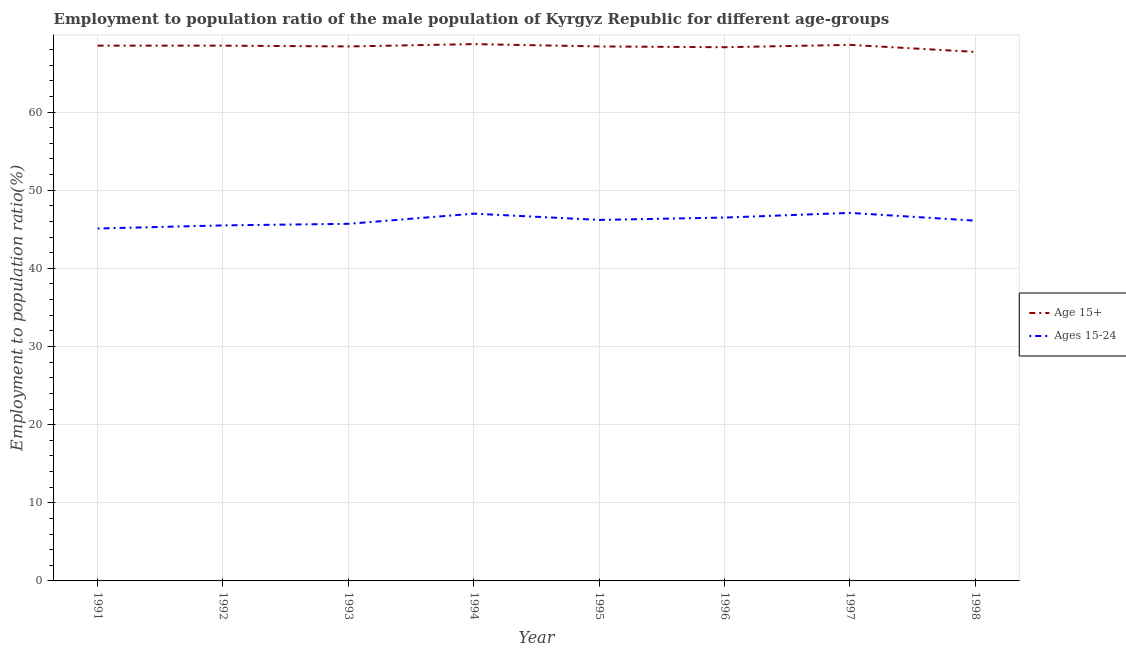How many different coloured lines are there?
Give a very brief answer. 2. Is the number of lines equal to the number of legend labels?
Provide a succinct answer. Yes. What is the employment to population ratio(age 15-24) in 1996?
Offer a terse response. 46.5. Across all years, what is the maximum employment to population ratio(age 15-24)?
Your response must be concise. 47.1. Across all years, what is the minimum employment to population ratio(age 15-24)?
Make the answer very short. 45.1. What is the total employment to population ratio(age 15-24) in the graph?
Keep it short and to the point. 369.2. What is the difference between the employment to population ratio(age 15+) in 1992 and that in 1998?
Provide a short and direct response. 0.8. What is the difference between the employment to population ratio(age 15-24) in 1991 and the employment to population ratio(age 15+) in 1994?
Offer a very short reply. -23.6. What is the average employment to population ratio(age 15-24) per year?
Make the answer very short. 46.15. In the year 1995, what is the difference between the employment to population ratio(age 15+) and employment to population ratio(age 15-24)?
Your response must be concise. 22.2. In how many years, is the employment to population ratio(age 15-24) greater than 18 %?
Ensure brevity in your answer.  8. What is the ratio of the employment to population ratio(age 15-24) in 1991 to that in 1998?
Offer a very short reply. 0.98. What is the difference between the highest and the second highest employment to population ratio(age 15-24)?
Your answer should be very brief. 0.1. In how many years, is the employment to population ratio(age 15-24) greater than the average employment to population ratio(age 15-24) taken over all years?
Offer a terse response. 4. What is the difference between two consecutive major ticks on the Y-axis?
Ensure brevity in your answer.  10. Does the graph contain any zero values?
Offer a terse response. No. Does the graph contain grids?
Provide a short and direct response. Yes. Where does the legend appear in the graph?
Give a very brief answer. Center right. How many legend labels are there?
Ensure brevity in your answer.  2. How are the legend labels stacked?
Make the answer very short. Vertical. What is the title of the graph?
Keep it short and to the point. Employment to population ratio of the male population of Kyrgyz Republic for different age-groups. Does "Manufacturing industries and construction" appear as one of the legend labels in the graph?
Your answer should be compact. No. What is the label or title of the X-axis?
Your answer should be compact. Year. What is the label or title of the Y-axis?
Offer a very short reply. Employment to population ratio(%). What is the Employment to population ratio(%) of Age 15+ in 1991?
Give a very brief answer. 68.5. What is the Employment to population ratio(%) in Ages 15-24 in 1991?
Give a very brief answer. 45.1. What is the Employment to population ratio(%) in Age 15+ in 1992?
Keep it short and to the point. 68.5. What is the Employment to population ratio(%) in Ages 15-24 in 1992?
Provide a short and direct response. 45.5. What is the Employment to population ratio(%) in Age 15+ in 1993?
Your response must be concise. 68.4. What is the Employment to population ratio(%) in Ages 15-24 in 1993?
Make the answer very short. 45.7. What is the Employment to population ratio(%) in Age 15+ in 1994?
Keep it short and to the point. 68.7. What is the Employment to population ratio(%) of Ages 15-24 in 1994?
Your response must be concise. 47. What is the Employment to population ratio(%) of Age 15+ in 1995?
Provide a short and direct response. 68.4. What is the Employment to population ratio(%) in Ages 15-24 in 1995?
Your answer should be very brief. 46.2. What is the Employment to population ratio(%) in Age 15+ in 1996?
Your answer should be very brief. 68.3. What is the Employment to population ratio(%) in Ages 15-24 in 1996?
Keep it short and to the point. 46.5. What is the Employment to population ratio(%) in Age 15+ in 1997?
Your response must be concise. 68.6. What is the Employment to population ratio(%) in Ages 15-24 in 1997?
Your answer should be compact. 47.1. What is the Employment to population ratio(%) in Age 15+ in 1998?
Ensure brevity in your answer.  67.7. What is the Employment to population ratio(%) in Ages 15-24 in 1998?
Provide a succinct answer. 46.1. Across all years, what is the maximum Employment to population ratio(%) of Age 15+?
Offer a very short reply. 68.7. Across all years, what is the maximum Employment to population ratio(%) in Ages 15-24?
Provide a succinct answer. 47.1. Across all years, what is the minimum Employment to population ratio(%) of Age 15+?
Make the answer very short. 67.7. Across all years, what is the minimum Employment to population ratio(%) of Ages 15-24?
Provide a succinct answer. 45.1. What is the total Employment to population ratio(%) of Age 15+ in the graph?
Your answer should be very brief. 547.1. What is the total Employment to population ratio(%) in Ages 15-24 in the graph?
Your answer should be compact. 369.2. What is the difference between the Employment to population ratio(%) in Age 15+ in 1991 and that in 1992?
Your answer should be compact. 0. What is the difference between the Employment to population ratio(%) in Ages 15-24 in 1991 and that in 1992?
Your answer should be compact. -0.4. What is the difference between the Employment to population ratio(%) of Age 15+ in 1991 and that in 1994?
Offer a terse response. -0.2. What is the difference between the Employment to population ratio(%) in Ages 15-24 in 1991 and that in 1994?
Keep it short and to the point. -1.9. What is the difference between the Employment to population ratio(%) in Ages 15-24 in 1991 and that in 1995?
Keep it short and to the point. -1.1. What is the difference between the Employment to population ratio(%) in Age 15+ in 1991 and that in 1997?
Provide a short and direct response. -0.1. What is the difference between the Employment to population ratio(%) in Ages 15-24 in 1991 and that in 1997?
Your answer should be compact. -2. What is the difference between the Employment to population ratio(%) in Age 15+ in 1991 and that in 1998?
Offer a very short reply. 0.8. What is the difference between the Employment to population ratio(%) of Ages 15-24 in 1992 and that in 1993?
Ensure brevity in your answer.  -0.2. What is the difference between the Employment to population ratio(%) in Age 15+ in 1992 and that in 1994?
Your answer should be very brief. -0.2. What is the difference between the Employment to population ratio(%) in Ages 15-24 in 1992 and that in 1994?
Keep it short and to the point. -1.5. What is the difference between the Employment to population ratio(%) of Ages 15-24 in 1992 and that in 1996?
Offer a very short reply. -1. What is the difference between the Employment to population ratio(%) in Ages 15-24 in 1992 and that in 1997?
Offer a very short reply. -1.6. What is the difference between the Employment to population ratio(%) of Age 15+ in 1992 and that in 1998?
Your answer should be compact. 0.8. What is the difference between the Employment to population ratio(%) in Ages 15-24 in 1992 and that in 1998?
Your answer should be very brief. -0.6. What is the difference between the Employment to population ratio(%) in Age 15+ in 1993 and that in 1994?
Your response must be concise. -0.3. What is the difference between the Employment to population ratio(%) of Ages 15-24 in 1993 and that in 1994?
Offer a terse response. -1.3. What is the difference between the Employment to population ratio(%) of Ages 15-24 in 1993 and that in 1995?
Ensure brevity in your answer.  -0.5. What is the difference between the Employment to population ratio(%) in Age 15+ in 1993 and that in 1996?
Your response must be concise. 0.1. What is the difference between the Employment to population ratio(%) in Ages 15-24 in 1993 and that in 1996?
Your answer should be compact. -0.8. What is the difference between the Employment to population ratio(%) in Age 15+ in 1993 and that in 1998?
Provide a short and direct response. 0.7. What is the difference between the Employment to population ratio(%) of Age 15+ in 1994 and that in 1995?
Your answer should be compact. 0.3. What is the difference between the Employment to population ratio(%) of Age 15+ in 1994 and that in 1996?
Provide a short and direct response. 0.4. What is the difference between the Employment to population ratio(%) in Ages 15-24 in 1994 and that in 1997?
Give a very brief answer. -0.1. What is the difference between the Employment to population ratio(%) of Ages 15-24 in 1994 and that in 1998?
Offer a terse response. 0.9. What is the difference between the Employment to population ratio(%) of Ages 15-24 in 1995 and that in 1996?
Make the answer very short. -0.3. What is the difference between the Employment to population ratio(%) of Age 15+ in 1995 and that in 1997?
Your answer should be compact. -0.2. What is the difference between the Employment to population ratio(%) of Ages 15-24 in 1995 and that in 1997?
Give a very brief answer. -0.9. What is the difference between the Employment to population ratio(%) of Age 15+ in 1995 and that in 1998?
Keep it short and to the point. 0.7. What is the difference between the Employment to population ratio(%) of Ages 15-24 in 1995 and that in 1998?
Your response must be concise. 0.1. What is the difference between the Employment to population ratio(%) in Age 15+ in 1996 and that in 1998?
Your answer should be compact. 0.6. What is the difference between the Employment to population ratio(%) of Age 15+ in 1991 and the Employment to population ratio(%) of Ages 15-24 in 1992?
Provide a succinct answer. 23. What is the difference between the Employment to population ratio(%) in Age 15+ in 1991 and the Employment to population ratio(%) in Ages 15-24 in 1993?
Keep it short and to the point. 22.8. What is the difference between the Employment to population ratio(%) in Age 15+ in 1991 and the Employment to population ratio(%) in Ages 15-24 in 1994?
Keep it short and to the point. 21.5. What is the difference between the Employment to population ratio(%) of Age 15+ in 1991 and the Employment to population ratio(%) of Ages 15-24 in 1995?
Keep it short and to the point. 22.3. What is the difference between the Employment to population ratio(%) in Age 15+ in 1991 and the Employment to population ratio(%) in Ages 15-24 in 1997?
Offer a terse response. 21.4. What is the difference between the Employment to population ratio(%) in Age 15+ in 1991 and the Employment to population ratio(%) in Ages 15-24 in 1998?
Give a very brief answer. 22.4. What is the difference between the Employment to population ratio(%) in Age 15+ in 1992 and the Employment to population ratio(%) in Ages 15-24 in 1993?
Your answer should be compact. 22.8. What is the difference between the Employment to population ratio(%) of Age 15+ in 1992 and the Employment to population ratio(%) of Ages 15-24 in 1994?
Your answer should be compact. 21.5. What is the difference between the Employment to population ratio(%) in Age 15+ in 1992 and the Employment to population ratio(%) in Ages 15-24 in 1995?
Keep it short and to the point. 22.3. What is the difference between the Employment to population ratio(%) in Age 15+ in 1992 and the Employment to population ratio(%) in Ages 15-24 in 1996?
Your answer should be compact. 22. What is the difference between the Employment to population ratio(%) in Age 15+ in 1992 and the Employment to population ratio(%) in Ages 15-24 in 1997?
Your answer should be very brief. 21.4. What is the difference between the Employment to population ratio(%) of Age 15+ in 1992 and the Employment to population ratio(%) of Ages 15-24 in 1998?
Keep it short and to the point. 22.4. What is the difference between the Employment to population ratio(%) in Age 15+ in 1993 and the Employment to population ratio(%) in Ages 15-24 in 1994?
Give a very brief answer. 21.4. What is the difference between the Employment to population ratio(%) of Age 15+ in 1993 and the Employment to population ratio(%) of Ages 15-24 in 1995?
Provide a short and direct response. 22.2. What is the difference between the Employment to population ratio(%) in Age 15+ in 1993 and the Employment to population ratio(%) in Ages 15-24 in 1996?
Give a very brief answer. 21.9. What is the difference between the Employment to population ratio(%) of Age 15+ in 1993 and the Employment to population ratio(%) of Ages 15-24 in 1997?
Offer a terse response. 21.3. What is the difference between the Employment to population ratio(%) in Age 15+ in 1993 and the Employment to population ratio(%) in Ages 15-24 in 1998?
Make the answer very short. 22.3. What is the difference between the Employment to population ratio(%) of Age 15+ in 1994 and the Employment to population ratio(%) of Ages 15-24 in 1995?
Give a very brief answer. 22.5. What is the difference between the Employment to population ratio(%) of Age 15+ in 1994 and the Employment to population ratio(%) of Ages 15-24 in 1996?
Make the answer very short. 22.2. What is the difference between the Employment to population ratio(%) of Age 15+ in 1994 and the Employment to population ratio(%) of Ages 15-24 in 1997?
Make the answer very short. 21.6. What is the difference between the Employment to population ratio(%) of Age 15+ in 1994 and the Employment to population ratio(%) of Ages 15-24 in 1998?
Give a very brief answer. 22.6. What is the difference between the Employment to population ratio(%) of Age 15+ in 1995 and the Employment to population ratio(%) of Ages 15-24 in 1996?
Make the answer very short. 21.9. What is the difference between the Employment to population ratio(%) in Age 15+ in 1995 and the Employment to population ratio(%) in Ages 15-24 in 1997?
Give a very brief answer. 21.3. What is the difference between the Employment to population ratio(%) of Age 15+ in 1995 and the Employment to population ratio(%) of Ages 15-24 in 1998?
Ensure brevity in your answer.  22.3. What is the difference between the Employment to population ratio(%) in Age 15+ in 1996 and the Employment to population ratio(%) in Ages 15-24 in 1997?
Your response must be concise. 21.2. What is the average Employment to population ratio(%) in Age 15+ per year?
Your answer should be very brief. 68.39. What is the average Employment to population ratio(%) of Ages 15-24 per year?
Your answer should be very brief. 46.15. In the year 1991, what is the difference between the Employment to population ratio(%) of Age 15+ and Employment to population ratio(%) of Ages 15-24?
Make the answer very short. 23.4. In the year 1992, what is the difference between the Employment to population ratio(%) of Age 15+ and Employment to population ratio(%) of Ages 15-24?
Ensure brevity in your answer.  23. In the year 1993, what is the difference between the Employment to population ratio(%) of Age 15+ and Employment to population ratio(%) of Ages 15-24?
Your response must be concise. 22.7. In the year 1994, what is the difference between the Employment to population ratio(%) of Age 15+ and Employment to population ratio(%) of Ages 15-24?
Give a very brief answer. 21.7. In the year 1996, what is the difference between the Employment to population ratio(%) in Age 15+ and Employment to population ratio(%) in Ages 15-24?
Your answer should be very brief. 21.8. In the year 1998, what is the difference between the Employment to population ratio(%) of Age 15+ and Employment to population ratio(%) of Ages 15-24?
Offer a terse response. 21.6. What is the ratio of the Employment to population ratio(%) in Age 15+ in 1991 to that in 1992?
Ensure brevity in your answer.  1. What is the ratio of the Employment to population ratio(%) in Ages 15-24 in 1991 to that in 1992?
Provide a short and direct response. 0.99. What is the ratio of the Employment to population ratio(%) in Age 15+ in 1991 to that in 1993?
Ensure brevity in your answer.  1. What is the ratio of the Employment to population ratio(%) in Ages 15-24 in 1991 to that in 1993?
Ensure brevity in your answer.  0.99. What is the ratio of the Employment to population ratio(%) in Ages 15-24 in 1991 to that in 1994?
Your response must be concise. 0.96. What is the ratio of the Employment to population ratio(%) in Ages 15-24 in 1991 to that in 1995?
Keep it short and to the point. 0.98. What is the ratio of the Employment to population ratio(%) in Ages 15-24 in 1991 to that in 1996?
Your answer should be compact. 0.97. What is the ratio of the Employment to population ratio(%) of Ages 15-24 in 1991 to that in 1997?
Offer a terse response. 0.96. What is the ratio of the Employment to population ratio(%) of Age 15+ in 1991 to that in 1998?
Provide a succinct answer. 1.01. What is the ratio of the Employment to population ratio(%) of Ages 15-24 in 1991 to that in 1998?
Your answer should be very brief. 0.98. What is the ratio of the Employment to population ratio(%) in Age 15+ in 1992 to that in 1994?
Provide a succinct answer. 1. What is the ratio of the Employment to population ratio(%) in Ages 15-24 in 1992 to that in 1994?
Provide a succinct answer. 0.97. What is the ratio of the Employment to population ratio(%) in Age 15+ in 1992 to that in 1995?
Give a very brief answer. 1. What is the ratio of the Employment to population ratio(%) of Ages 15-24 in 1992 to that in 1995?
Make the answer very short. 0.98. What is the ratio of the Employment to population ratio(%) in Age 15+ in 1992 to that in 1996?
Make the answer very short. 1. What is the ratio of the Employment to population ratio(%) in Ages 15-24 in 1992 to that in 1996?
Your answer should be compact. 0.98. What is the ratio of the Employment to population ratio(%) in Age 15+ in 1992 to that in 1997?
Offer a terse response. 1. What is the ratio of the Employment to population ratio(%) of Age 15+ in 1992 to that in 1998?
Provide a short and direct response. 1.01. What is the ratio of the Employment to population ratio(%) in Age 15+ in 1993 to that in 1994?
Ensure brevity in your answer.  1. What is the ratio of the Employment to population ratio(%) in Ages 15-24 in 1993 to that in 1994?
Offer a very short reply. 0.97. What is the ratio of the Employment to population ratio(%) in Age 15+ in 1993 to that in 1995?
Your answer should be very brief. 1. What is the ratio of the Employment to population ratio(%) in Ages 15-24 in 1993 to that in 1996?
Your answer should be very brief. 0.98. What is the ratio of the Employment to population ratio(%) of Ages 15-24 in 1993 to that in 1997?
Provide a short and direct response. 0.97. What is the ratio of the Employment to population ratio(%) of Age 15+ in 1993 to that in 1998?
Your answer should be compact. 1.01. What is the ratio of the Employment to population ratio(%) of Ages 15-24 in 1994 to that in 1995?
Keep it short and to the point. 1.02. What is the ratio of the Employment to population ratio(%) of Age 15+ in 1994 to that in 1996?
Give a very brief answer. 1.01. What is the ratio of the Employment to population ratio(%) of Ages 15-24 in 1994 to that in 1996?
Provide a short and direct response. 1.01. What is the ratio of the Employment to population ratio(%) of Age 15+ in 1994 to that in 1997?
Offer a very short reply. 1. What is the ratio of the Employment to population ratio(%) of Age 15+ in 1994 to that in 1998?
Your answer should be compact. 1.01. What is the ratio of the Employment to population ratio(%) in Ages 15-24 in 1994 to that in 1998?
Provide a short and direct response. 1.02. What is the ratio of the Employment to population ratio(%) of Age 15+ in 1995 to that in 1996?
Give a very brief answer. 1. What is the ratio of the Employment to population ratio(%) of Age 15+ in 1995 to that in 1997?
Offer a terse response. 1. What is the ratio of the Employment to population ratio(%) of Ages 15-24 in 1995 to that in 1997?
Ensure brevity in your answer.  0.98. What is the ratio of the Employment to population ratio(%) of Age 15+ in 1995 to that in 1998?
Make the answer very short. 1.01. What is the ratio of the Employment to population ratio(%) in Ages 15-24 in 1996 to that in 1997?
Keep it short and to the point. 0.99. What is the ratio of the Employment to population ratio(%) in Age 15+ in 1996 to that in 1998?
Give a very brief answer. 1.01. What is the ratio of the Employment to population ratio(%) in Ages 15-24 in 1996 to that in 1998?
Provide a succinct answer. 1.01. What is the ratio of the Employment to population ratio(%) of Age 15+ in 1997 to that in 1998?
Your answer should be compact. 1.01. What is the ratio of the Employment to population ratio(%) of Ages 15-24 in 1997 to that in 1998?
Offer a very short reply. 1.02. What is the difference between the highest and the second highest Employment to population ratio(%) of Age 15+?
Provide a short and direct response. 0.1. What is the difference between the highest and the second highest Employment to population ratio(%) of Ages 15-24?
Offer a terse response. 0.1. What is the difference between the highest and the lowest Employment to population ratio(%) of Ages 15-24?
Your answer should be compact. 2. 